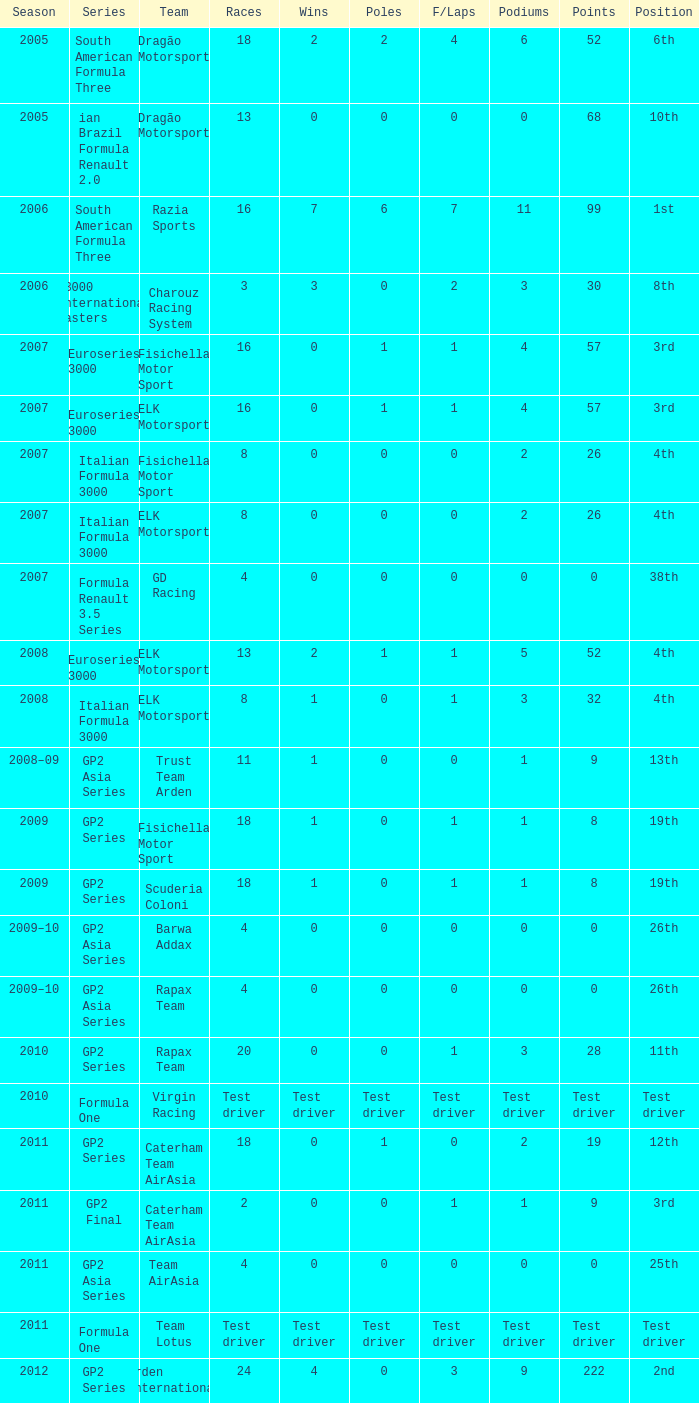When were the moments in the year where he achieved five podiums? 52.0. 